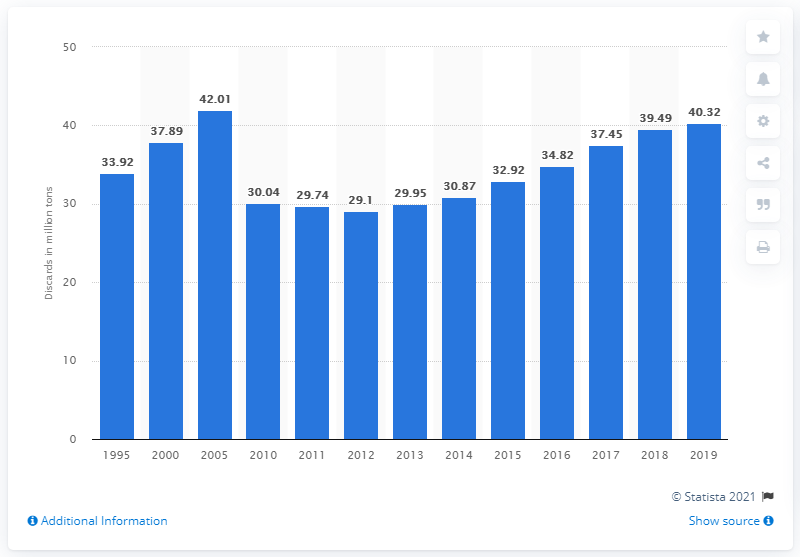Specify some key components in this picture. Since 2012, the amount of municipal solid waste landfilled in California has increased. In 2019, 40,320,000 metric tons of municipal solid waste were disposed of in landfills in California. 